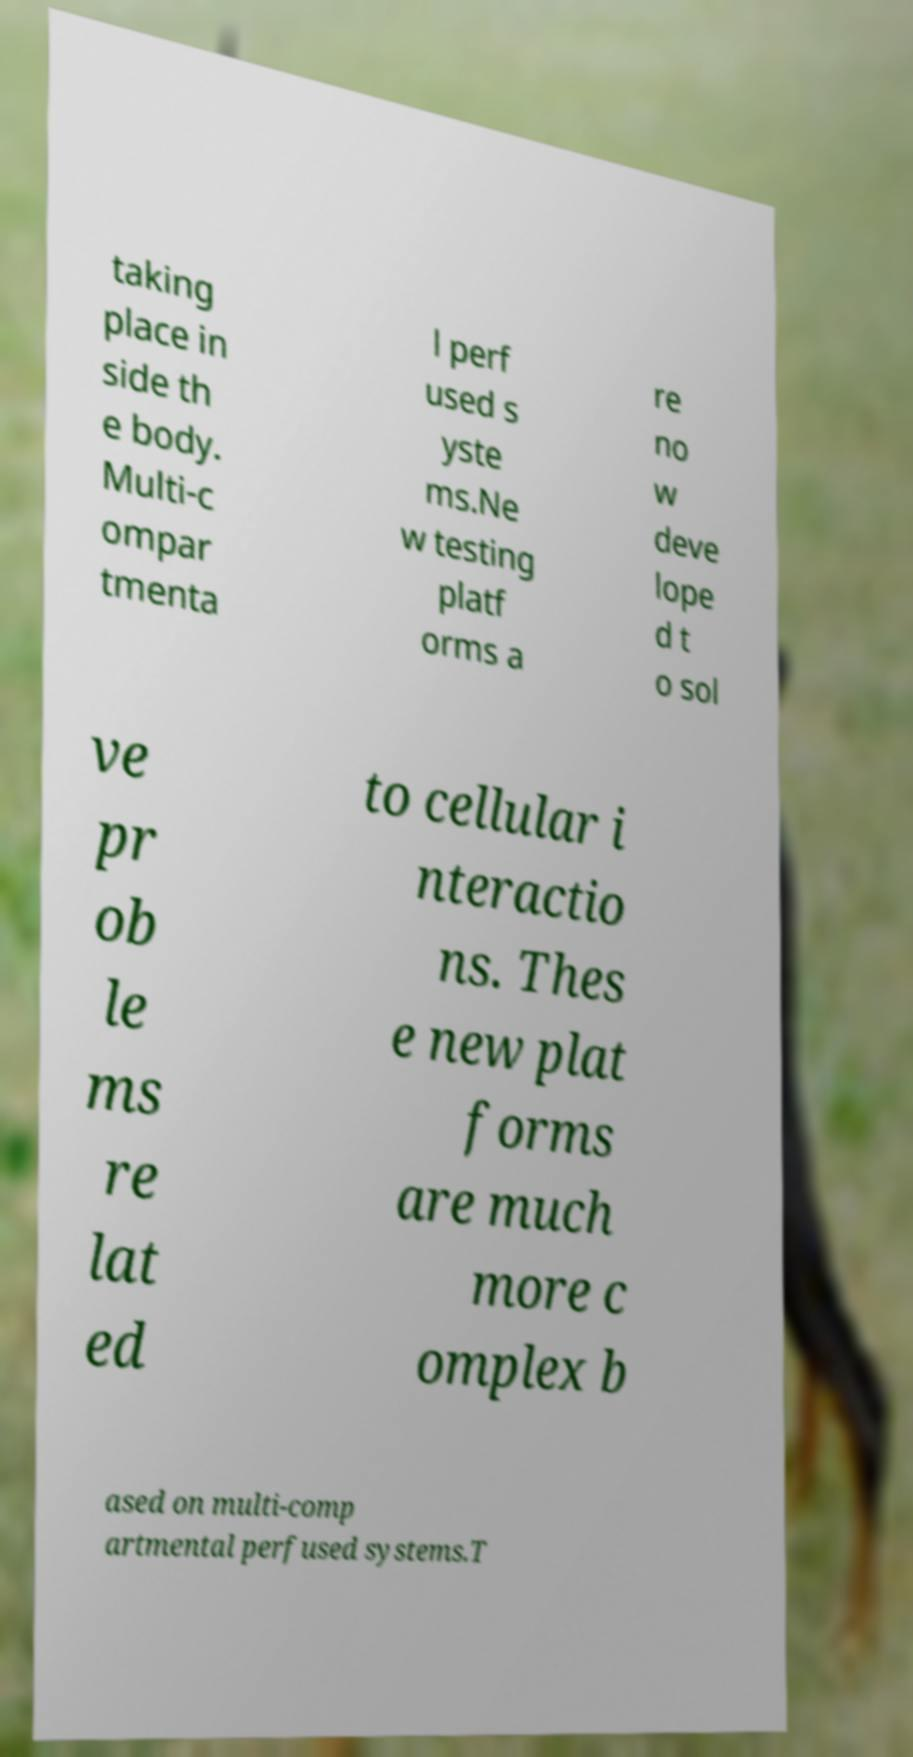What messages or text are displayed in this image? I need them in a readable, typed format. taking place in side th e body. Multi-c ompar tmenta l perf used s yste ms.Ne w testing platf orms a re no w deve lope d t o sol ve pr ob le ms re lat ed to cellular i nteractio ns. Thes e new plat forms are much more c omplex b ased on multi-comp artmental perfused systems.T 